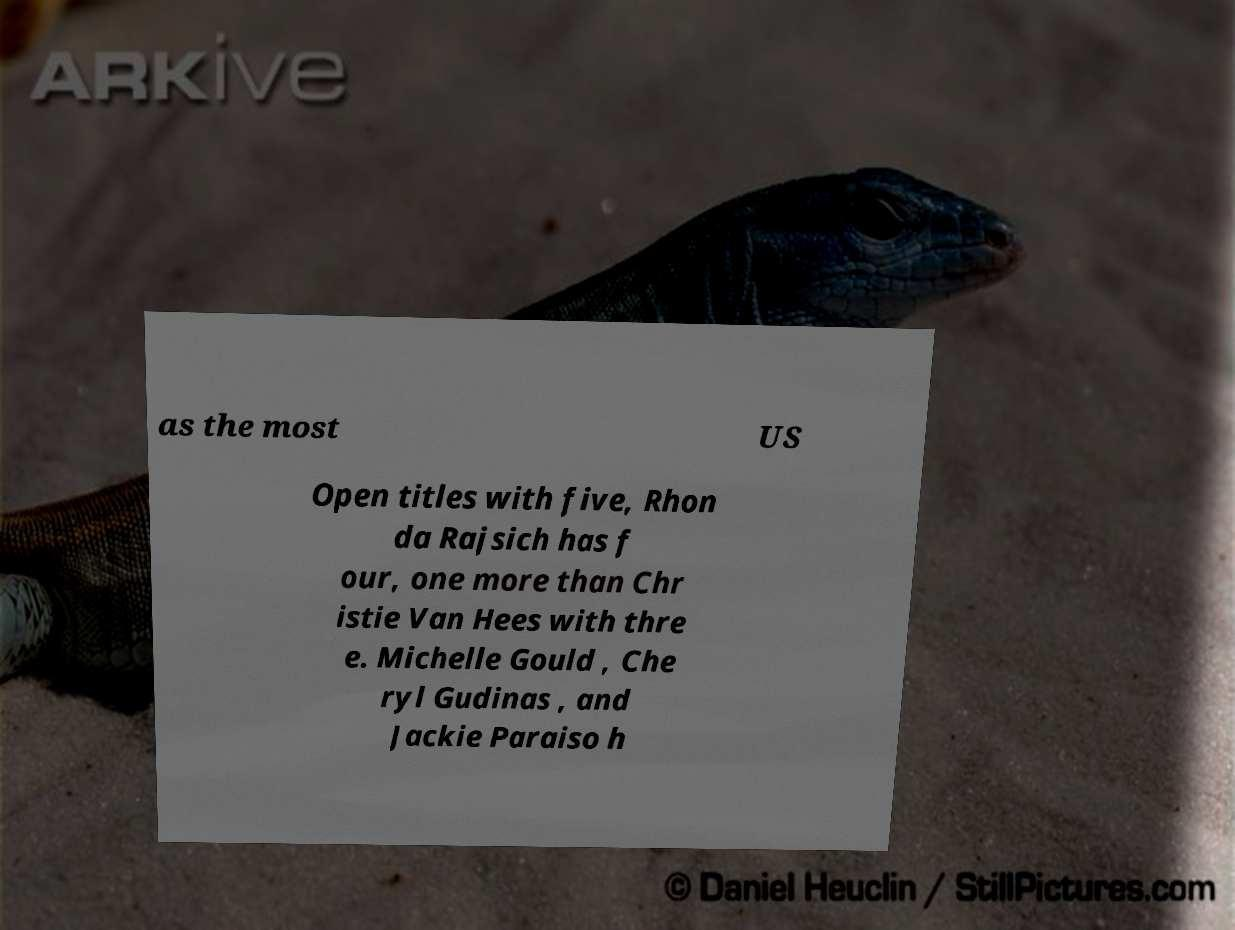Can you accurately transcribe the text from the provided image for me? as the most US Open titles with five, Rhon da Rajsich has f our, one more than Chr istie Van Hees with thre e. Michelle Gould , Che ryl Gudinas , and Jackie Paraiso h 